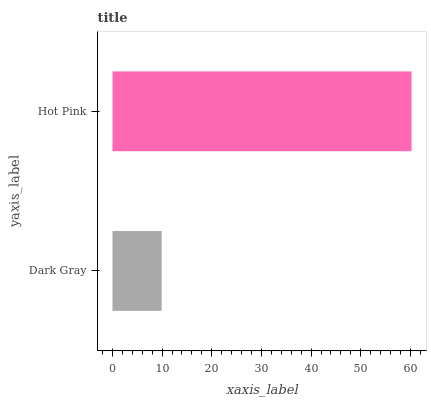Is Dark Gray the minimum?
Answer yes or no. Yes. Is Hot Pink the maximum?
Answer yes or no. Yes. Is Hot Pink the minimum?
Answer yes or no. No. Is Hot Pink greater than Dark Gray?
Answer yes or no. Yes. Is Dark Gray less than Hot Pink?
Answer yes or no. Yes. Is Dark Gray greater than Hot Pink?
Answer yes or no. No. Is Hot Pink less than Dark Gray?
Answer yes or no. No. Is Hot Pink the high median?
Answer yes or no. Yes. Is Dark Gray the low median?
Answer yes or no. Yes. Is Dark Gray the high median?
Answer yes or no. No. Is Hot Pink the low median?
Answer yes or no. No. 